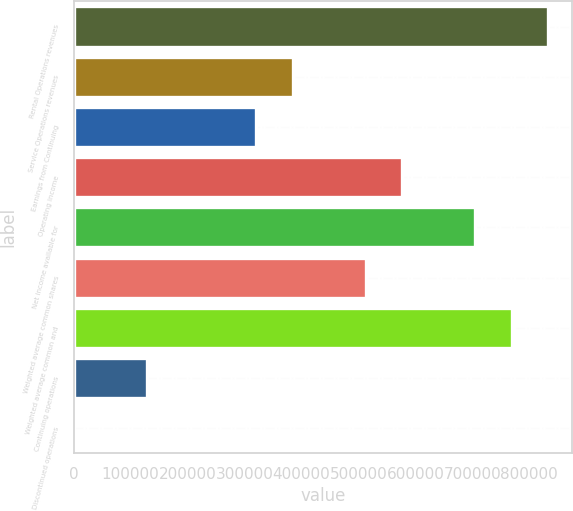<chart> <loc_0><loc_0><loc_500><loc_500><bar_chart><fcel>Rental Operations revenues<fcel>Service Operations revenues<fcel>Earnings from Continuing<fcel>Operating income<fcel>Net income available for<fcel>Weighted average common shares<fcel>Weighted average common and<fcel>Continuing operations<fcel>Discontinued operations<nl><fcel>833501<fcel>384693<fcel>320578<fcel>577040<fcel>705270<fcel>512924<fcel>769386<fcel>128231<fcel>0.31<nl></chart> 